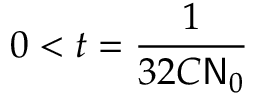Convert formula to latex. <formula><loc_0><loc_0><loc_500><loc_500>0 < t = \frac { 1 } { 3 2 C N _ { 0 } }</formula> 